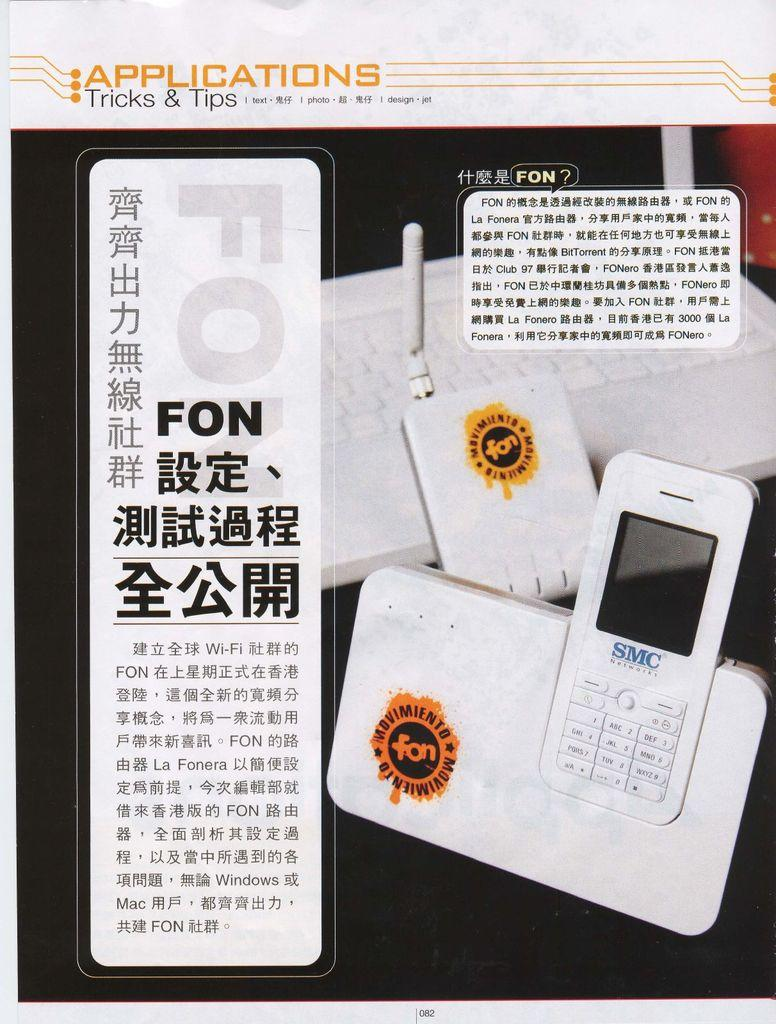<image>
Summarize the visual content of the image. A white SMC Networks phone sits in a white holder on a desk. 